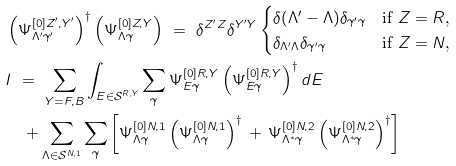<formula> <loc_0><loc_0><loc_500><loc_500>& \left ( \Psi ^ { [ 0 ] Z ^ { \prime } , Y ^ { \prime } } _ { \Lambda ^ { \prime } \gamma ^ { \prime } } \right ) ^ { \dagger } \left ( \Psi ^ { [ 0 ] Z , Y } _ { \Lambda \gamma } \right ) \ = \ \delta ^ { Z ^ { \prime } Z } \delta ^ { Y ^ { \prime } Y } \begin{cases} \delta ( \Lambda ^ { \prime } - \Lambda ) \delta _ { \gamma ^ { \prime } \gamma } & \text {if $Z=R$,} \\ \delta _ { \Lambda ^ { \prime } \Lambda } \delta _ { \gamma ^ { \prime } \gamma } & \text {if $Z=N$,} \end{cases} \\ & I \ = \ \sum _ { Y = F , B } \int _ { E \in { \mathcal { S } } ^ { R , Y } } \sum _ { \gamma } \Psi ^ { [ 0 ] R , Y } _ { E \gamma } \left ( \Psi ^ { [ 0 ] R , Y } _ { E \gamma } \right ) ^ { \dagger } d E \\ & \quad + \sum _ { \Lambda \in { \mathcal { S } } ^ { N , 1 } } \sum _ { \gamma } \left [ \Psi ^ { [ 0 ] N , 1 } _ { \Lambda \gamma } \left ( \Psi ^ { [ 0 ] N , 1 } _ { \Lambda \gamma } \right ) ^ { \dagger } \, + \, \Psi ^ { [ 0 ] N , 2 } _ { \Lambda ^ { \ast } \gamma } \left ( \Psi ^ { [ 0 ] N , 2 } _ { \Lambda ^ { \ast } \gamma } \right ) ^ { \dagger } \right ]</formula> 